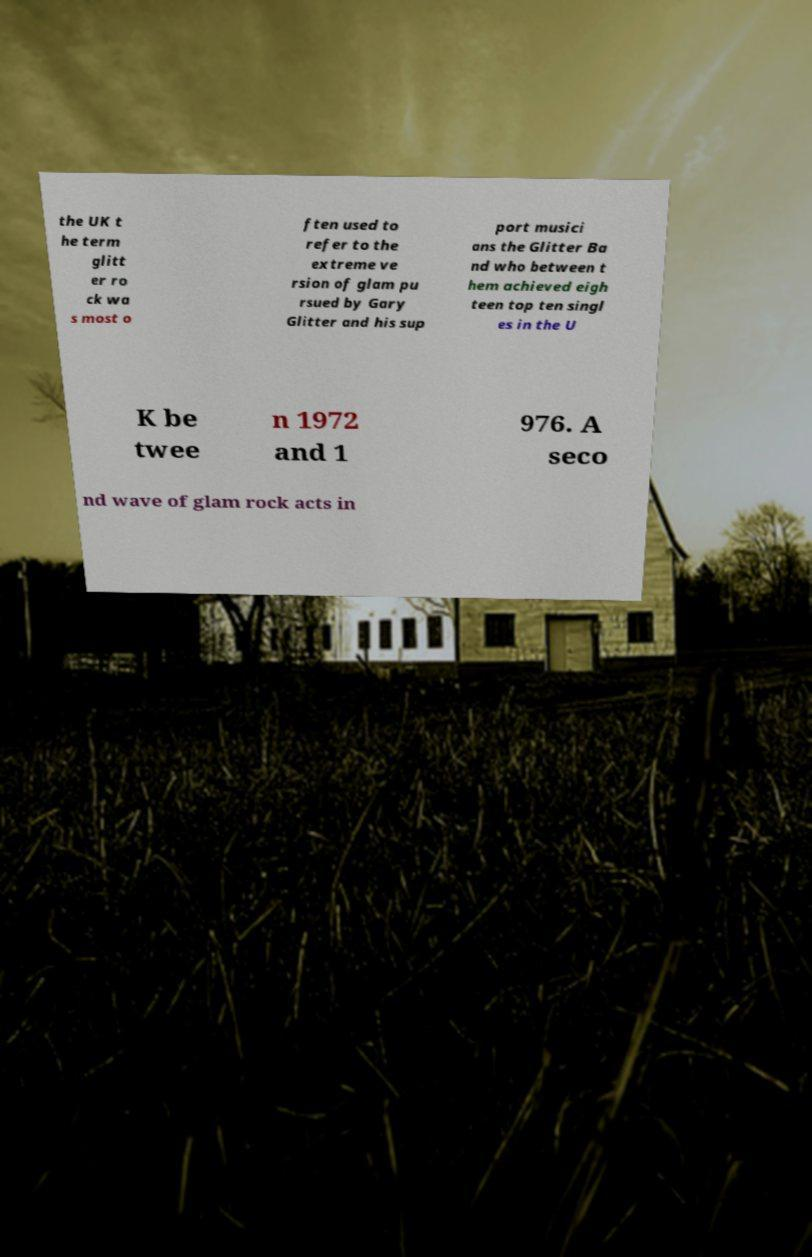I need the written content from this picture converted into text. Can you do that? the UK t he term glitt er ro ck wa s most o ften used to refer to the extreme ve rsion of glam pu rsued by Gary Glitter and his sup port musici ans the Glitter Ba nd who between t hem achieved eigh teen top ten singl es in the U K be twee n 1972 and 1 976. A seco nd wave of glam rock acts in 